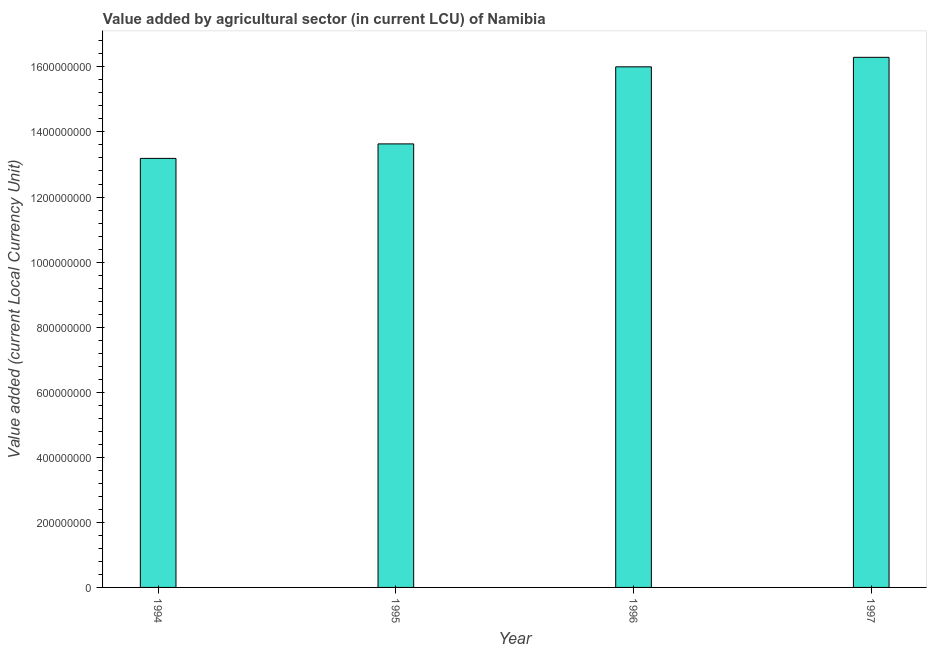Does the graph contain any zero values?
Offer a terse response. No. What is the title of the graph?
Keep it short and to the point. Value added by agricultural sector (in current LCU) of Namibia. What is the label or title of the Y-axis?
Your response must be concise. Value added (current Local Currency Unit). What is the value added by agriculture sector in 1994?
Provide a succinct answer. 1.32e+09. Across all years, what is the maximum value added by agriculture sector?
Ensure brevity in your answer.  1.63e+09. Across all years, what is the minimum value added by agriculture sector?
Ensure brevity in your answer.  1.32e+09. In which year was the value added by agriculture sector maximum?
Provide a succinct answer. 1997. In which year was the value added by agriculture sector minimum?
Keep it short and to the point. 1994. What is the sum of the value added by agriculture sector?
Make the answer very short. 5.91e+09. What is the difference between the value added by agriculture sector in 1995 and 1996?
Ensure brevity in your answer.  -2.37e+08. What is the average value added by agriculture sector per year?
Provide a short and direct response. 1.48e+09. What is the median value added by agriculture sector?
Your response must be concise. 1.48e+09. In how many years, is the value added by agriculture sector greater than 600000000 LCU?
Your answer should be compact. 4. What is the ratio of the value added by agriculture sector in 1995 to that in 1996?
Your answer should be very brief. 0.85. Is the difference between the value added by agriculture sector in 1995 and 1997 greater than the difference between any two years?
Keep it short and to the point. No. What is the difference between the highest and the second highest value added by agriculture sector?
Your answer should be very brief. 2.92e+07. Is the sum of the value added by agriculture sector in 1994 and 1996 greater than the maximum value added by agriculture sector across all years?
Offer a very short reply. Yes. What is the difference between the highest and the lowest value added by agriculture sector?
Offer a terse response. 3.11e+08. Are all the bars in the graph horizontal?
Keep it short and to the point. No. How many years are there in the graph?
Keep it short and to the point. 4. What is the difference between two consecutive major ticks on the Y-axis?
Provide a short and direct response. 2.00e+08. What is the Value added (current Local Currency Unit) of 1994?
Your answer should be very brief. 1.32e+09. What is the Value added (current Local Currency Unit) in 1995?
Provide a succinct answer. 1.36e+09. What is the Value added (current Local Currency Unit) of 1996?
Your answer should be very brief. 1.60e+09. What is the Value added (current Local Currency Unit) in 1997?
Your response must be concise. 1.63e+09. What is the difference between the Value added (current Local Currency Unit) in 1994 and 1995?
Your response must be concise. -4.46e+07. What is the difference between the Value added (current Local Currency Unit) in 1994 and 1996?
Provide a succinct answer. -2.81e+08. What is the difference between the Value added (current Local Currency Unit) in 1994 and 1997?
Your response must be concise. -3.11e+08. What is the difference between the Value added (current Local Currency Unit) in 1995 and 1996?
Make the answer very short. -2.37e+08. What is the difference between the Value added (current Local Currency Unit) in 1995 and 1997?
Keep it short and to the point. -2.66e+08. What is the difference between the Value added (current Local Currency Unit) in 1996 and 1997?
Give a very brief answer. -2.92e+07. What is the ratio of the Value added (current Local Currency Unit) in 1994 to that in 1995?
Offer a terse response. 0.97. What is the ratio of the Value added (current Local Currency Unit) in 1994 to that in 1996?
Offer a terse response. 0.82. What is the ratio of the Value added (current Local Currency Unit) in 1994 to that in 1997?
Give a very brief answer. 0.81. What is the ratio of the Value added (current Local Currency Unit) in 1995 to that in 1996?
Offer a terse response. 0.85. What is the ratio of the Value added (current Local Currency Unit) in 1995 to that in 1997?
Give a very brief answer. 0.84. What is the ratio of the Value added (current Local Currency Unit) in 1996 to that in 1997?
Make the answer very short. 0.98. 